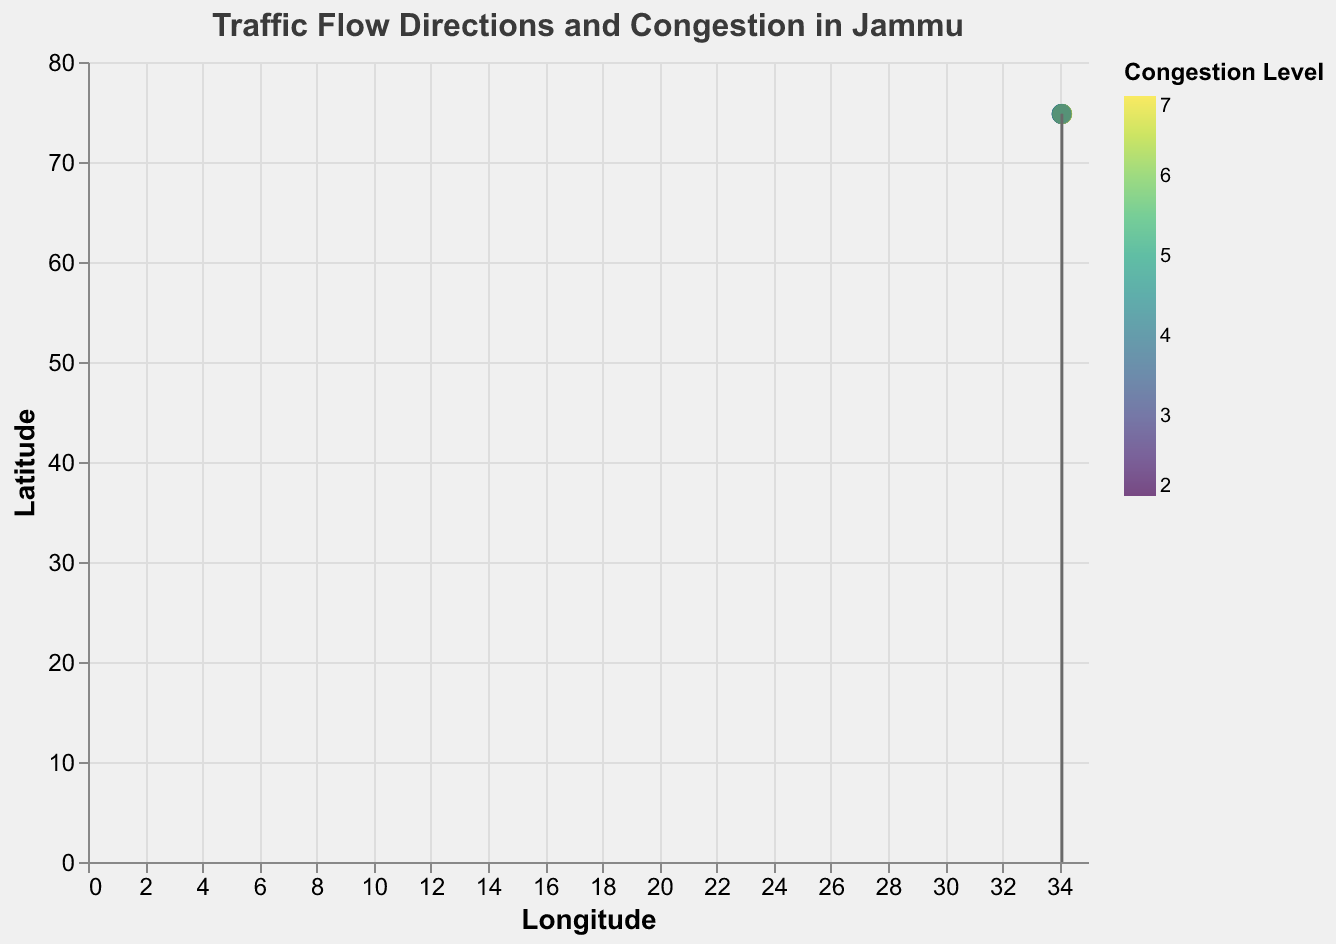What is the title of the plot? The title is located at the top of the plot and specifies the purpose of the visualization. It reads: "Traffic Flow Directions and Congestion in Jammu".
Answer: Traffic Flow Directions and Congestion in Jammu How many data points are represented in the plot? Count the number of points (circles) shown on the plot. Each point represents a data entry.
Answer: 10 What do the colors in the plot represent? Refer to the legend on the right side of the plot which explains the color coding. The colors represent different levels of congestion.
Answer: Congestion Level Which location has the highest congestion level? Look for the data point with the highest magnitude value, indicated by the tooltip and the darkest color according to the viridis color scheme. The point at (34.0986, 74.7945) has a magnitude of 7.
Answer: (34.0986, 74.7945) What are the longitude and latitude ranges covered by the plot? Look at the x-axis (Longitude) and y-axis (Latitude) to determine the range of values covered. The longitude ranges approximately from 34.0789 to 34.0986, and the latitude ranges from 74.7891 to 74.8174.
Answer: Longitude: 34.0789 to 34.0986, Latitude: 74.7891 to 74.8174 What is the direction of the traffic flow at location (34.0836, 74.7973)? Find the data point with coordinates (34.0836, 74.7973), then look at the direction of the arrow (quiver) originating from this point. The arrow points to the left and slightly up (-0.8, 0.2).
Answer: Left and slightly up Which location has the lowest congestion level and what is the traffic flow direction there? Identify the data point with the lowest magnitude value, which is 2 at (34.0867, 74.7919). The direction of the traffic flow there is right and up (0.6, 0.4).
Answer: (34.0867, 74.7919) and up-right What are the directional components of the traffic flow at (34.0867, 74.7919)? For the given coordinate, the directional components are defined by 'u' and 'v' values. Here, 'u' is 0.6 and 'v' is 0.4.
Answer: 0.6 and 0.4 Which location has a moderate congestion level of 4, and what direction is the traffic flowing there? Find data points with a magnitude of 4. They are at (34.0789, 74.8020), (34.0925, 74.7891), and (34.0803, 74.8067). The respective traffic flow directions are (-0.5, -0.3), (-0.4, 0.5), and (0.5, 0.8).
Answer: (34.0789, 74.8020), (34.0925, 74.7891), (34.0803, 74.8067) What is the traffic flow direction at location (34.0911, 74.8056) during peak commute times? Refer to the specified coordinates and observe the direction of the corresponding arrow. The arrow points right and down (0.3, -0.7).
Answer: Right and down 